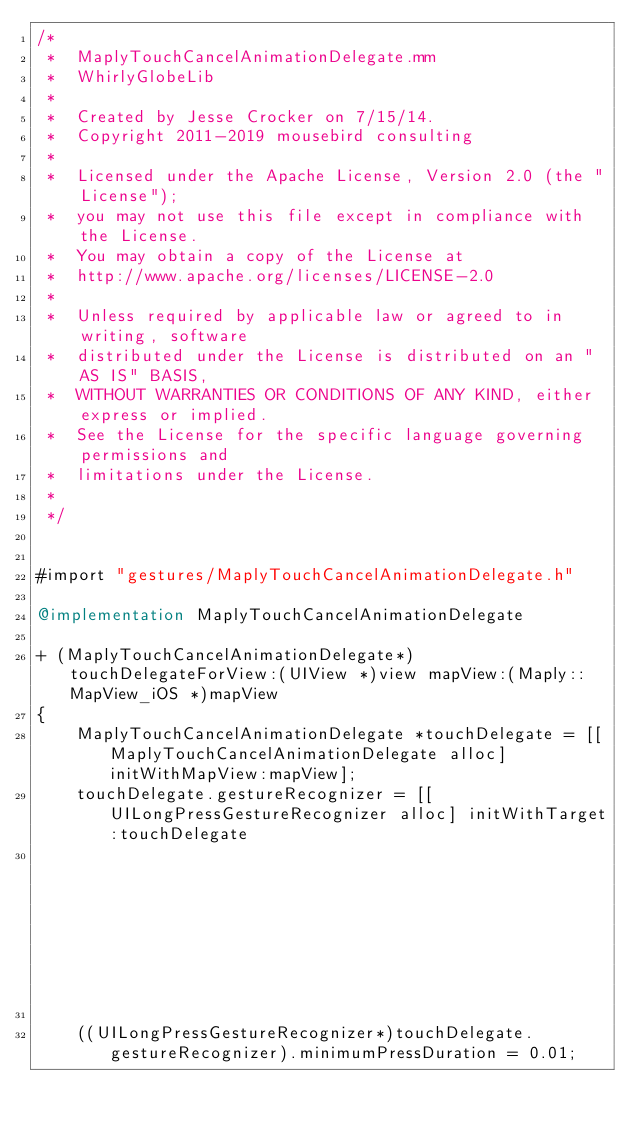Convert code to text. <code><loc_0><loc_0><loc_500><loc_500><_ObjectiveC_>/*
 *  MaplyTouchCancelAnimationDelegate.mm
 *  WhirlyGlobeLib
 *
 *  Created by Jesse Crocker on 7/15/14.
 *  Copyright 2011-2019 mousebird consulting
 *
 *  Licensed under the Apache License, Version 2.0 (the "License");
 *  you may not use this file except in compliance with the License.
 *  You may obtain a copy of the License at
 *  http://www.apache.org/licenses/LICENSE-2.0
 *
 *  Unless required by applicable law or agreed to in writing, software
 *  distributed under the License is distributed on an "AS IS" BASIS,
 *  WITHOUT WARRANTIES OR CONDITIONS OF ANY KIND, either express or implied.
 *  See the License for the specific language governing permissions and
 *  limitations under the License.
 *
 */


#import "gestures/MaplyTouchCancelAnimationDelegate.h"

@implementation MaplyTouchCancelAnimationDelegate

+ (MaplyTouchCancelAnimationDelegate*)touchDelegateForView:(UIView *)view mapView:(Maply::MapView_iOS *)mapView
{
    MaplyTouchCancelAnimationDelegate *touchDelegate = [[MaplyTouchCancelAnimationDelegate alloc] initWithMapView:mapView];
    touchDelegate.gestureRecognizer = [[UILongPressGestureRecognizer alloc] initWithTarget:touchDelegate
                                                                                    action:@selector(touchGesture:)];

    ((UILongPressGestureRecognizer*)touchDelegate.gestureRecognizer).minimumPressDuration = 0.01;</code> 